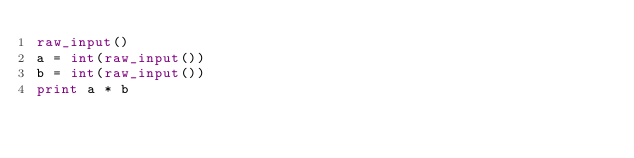Convert code to text. <code><loc_0><loc_0><loc_500><loc_500><_Python_>raw_input()
a = int(raw_input())
b = int(raw_input())
print a * b</code> 